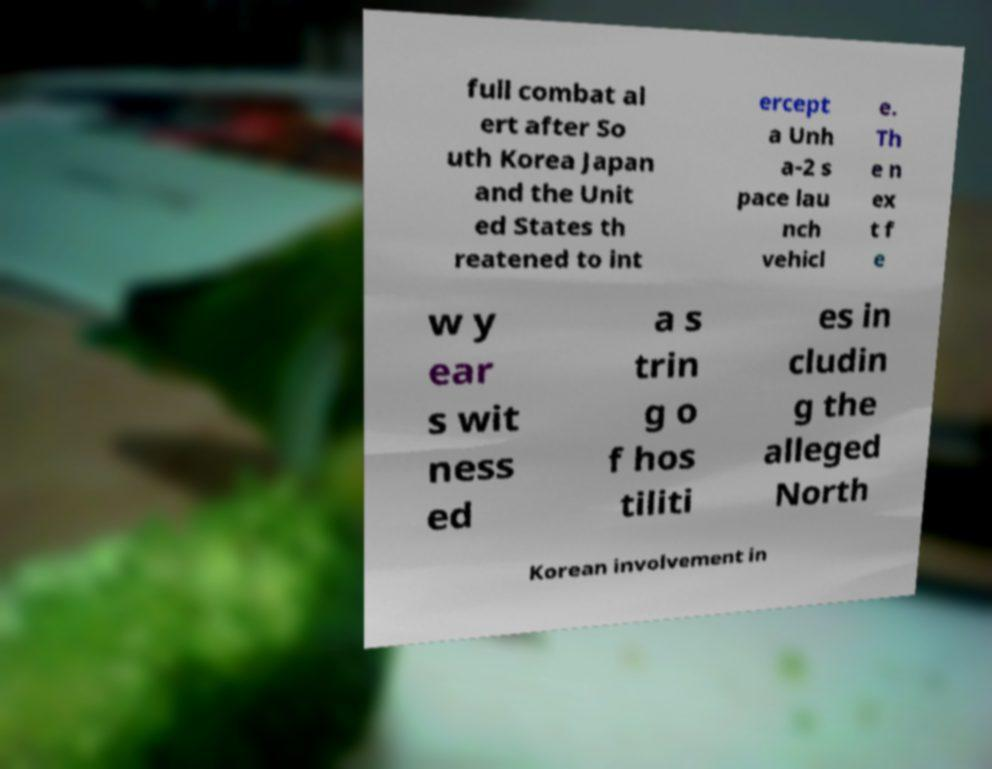For documentation purposes, I need the text within this image transcribed. Could you provide that? full combat al ert after So uth Korea Japan and the Unit ed States th reatened to int ercept a Unh a-2 s pace lau nch vehicl e. Th e n ex t f e w y ear s wit ness ed a s trin g o f hos tiliti es in cludin g the alleged North Korean involvement in 